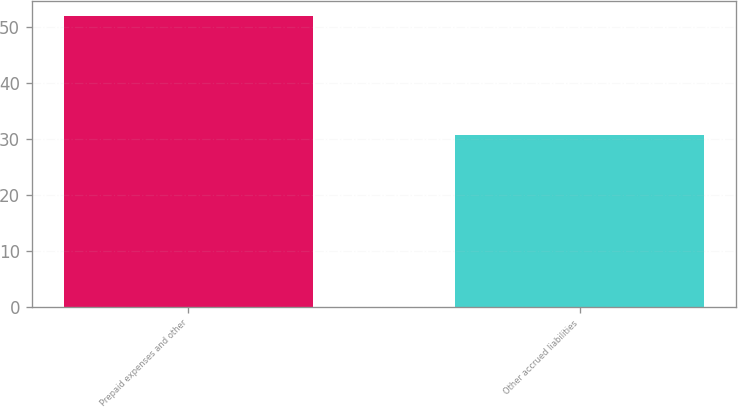<chart> <loc_0><loc_0><loc_500><loc_500><bar_chart><fcel>Prepaid expenses and other<fcel>Other accrued liabilities<nl><fcel>52.1<fcel>30.8<nl></chart> 